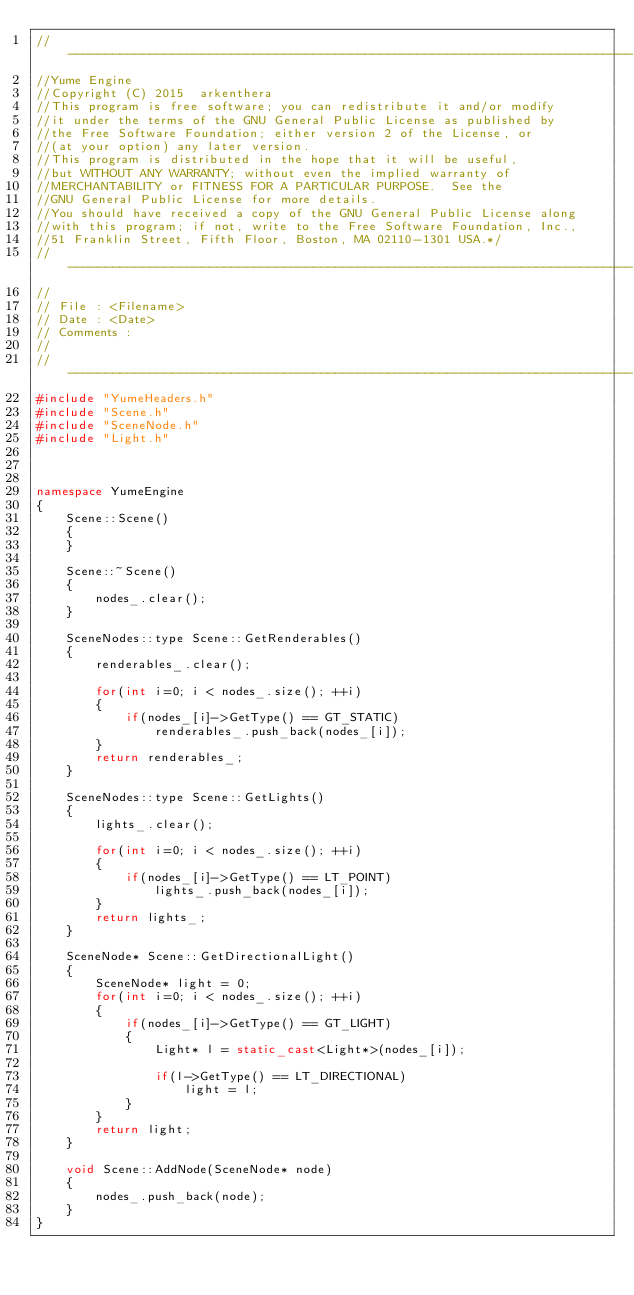<code> <loc_0><loc_0><loc_500><loc_500><_C++_>//----------------------------------------------------------------------------
//Yume Engine
//Copyright (C) 2015  arkenthera
//This program is free software; you can redistribute it and/or modify
//it under the terms of the GNU General Public License as published by
//the Free Software Foundation; either version 2 of the License, or
//(at your option) any later version.
//This program is distributed in the hope that it will be useful,
//but WITHOUT ANY WARRANTY; without even the implied warranty of
//MERCHANTABILITY or FITNESS FOR A PARTICULAR PURPOSE.  See the
//GNU General Public License for more details.
//You should have received a copy of the GNU General Public License along
//with this program; if not, write to the Free Software Foundation, Inc.,
//51 Franklin Street, Fifth Floor, Boston, MA 02110-1301 USA.*/
//----------------------------------------------------------------------------
//
// File : <Filename>
// Date : <Date>
// Comments :
//
//----------------------------------------------------------------------------
#include "YumeHeaders.h"
#include "Scene.h"
#include "SceneNode.h"
#include "Light.h"



namespace YumeEngine
{
	Scene::Scene()
	{
	}

	Scene::~Scene()
	{
		nodes_.clear();
	}

	SceneNodes::type Scene::GetRenderables()
	{
		renderables_.clear();

		for(int i=0; i < nodes_.size(); ++i)
		{
			if(nodes_[i]->GetType() == GT_STATIC)
				renderables_.push_back(nodes_[i]);
		}
		return renderables_;
	}

	SceneNodes::type Scene::GetLights()
	{
		lights_.clear();

		for(int i=0; i < nodes_.size(); ++i)
		{
			if(nodes_[i]->GetType() == LT_POINT)
				lights_.push_back(nodes_[i]);
		}
		return lights_;
	}

	SceneNode* Scene::GetDirectionalLight()
	{
		SceneNode* light = 0;
		for(int i=0; i < nodes_.size(); ++i)
		{
			if(nodes_[i]->GetType() == GT_LIGHT)
			{
				Light* l = static_cast<Light*>(nodes_[i]);

				if(l->GetType() == LT_DIRECTIONAL)
					light = l;
			}
		}
		return light;
	}

	void Scene::AddNode(SceneNode* node)
	{
		nodes_.push_back(node);
	}
}
</code> 